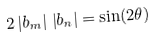<formula> <loc_0><loc_0><loc_500><loc_500>2 \left | b _ { m } \right | \, \left | b _ { n } \right | = \sin ( 2 \theta )</formula> 